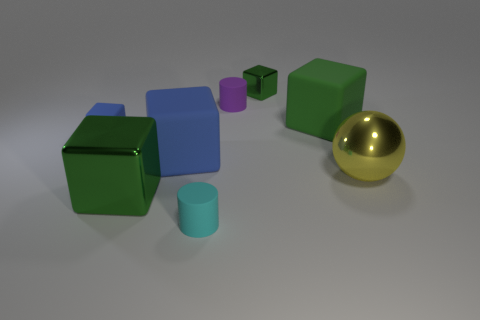What number of blocks are red things or big blue rubber things?
Give a very brief answer. 1. What material is the green object to the left of the tiny green block?
Offer a very short reply. Metal. There is a rubber thing that is the same color as the small rubber cube; what size is it?
Your response must be concise. Large. Is the color of the large thing that is left of the big blue cube the same as the rubber object that is right of the tiny green cube?
Your answer should be compact. Yes. How many things are tiny green objects or large yellow metal spheres?
Your answer should be compact. 2. What number of other things are the same shape as the big blue object?
Your answer should be very brief. 4. Is the large block in front of the yellow shiny ball made of the same material as the large block right of the tiny purple object?
Your answer should be very brief. No. What shape is the metallic object that is both on the left side of the big yellow sphere and on the right side of the purple thing?
Provide a short and direct response. Cube. Is there any other thing that has the same material as the tiny cyan thing?
Your answer should be compact. Yes. There is a green thing that is both in front of the purple rubber cylinder and right of the tiny purple matte thing; what material is it made of?
Your response must be concise. Rubber. 